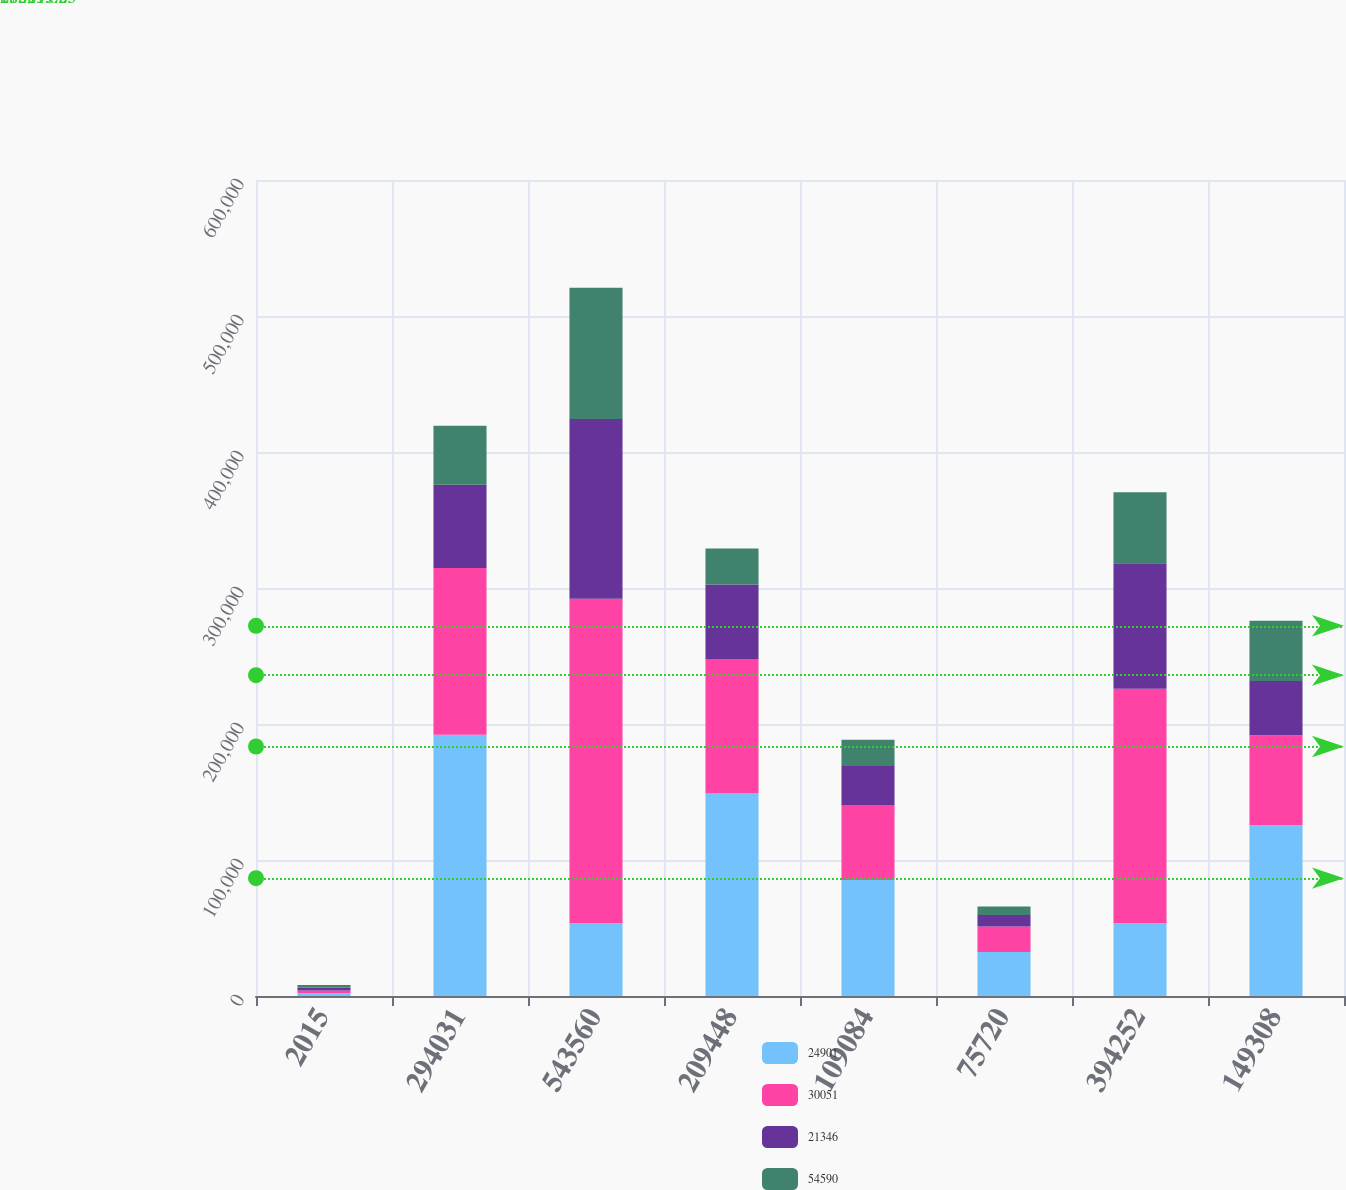Convert chart. <chart><loc_0><loc_0><loc_500><loc_500><stacked_bar_chart><ecel><fcel>2015<fcel>294031<fcel>543560<fcel>209448<fcel>109084<fcel>75720<fcel>394252<fcel>149308<nl><fcel>24901<fcel>2014<fcel>192015<fcel>53598.5<fcel>148909<fcel>85338<fcel>32331<fcel>53598.5<fcel>125513<nl><fcel>30051<fcel>2013<fcel>122686<fcel>238538<fcel>98587<fcel>55115<fcel>18688<fcel>172390<fcel>66148<nl><fcel>21346<fcel>2012<fcel>61252<fcel>132156<fcel>55155<fcel>28603<fcel>8501<fcel>92259<fcel>39897<nl><fcel>54590<fcel>2011<fcel>43366<fcel>96482<fcel>26408<fcel>19450<fcel>6224<fcel>52082<fcel>44400<nl></chart> 